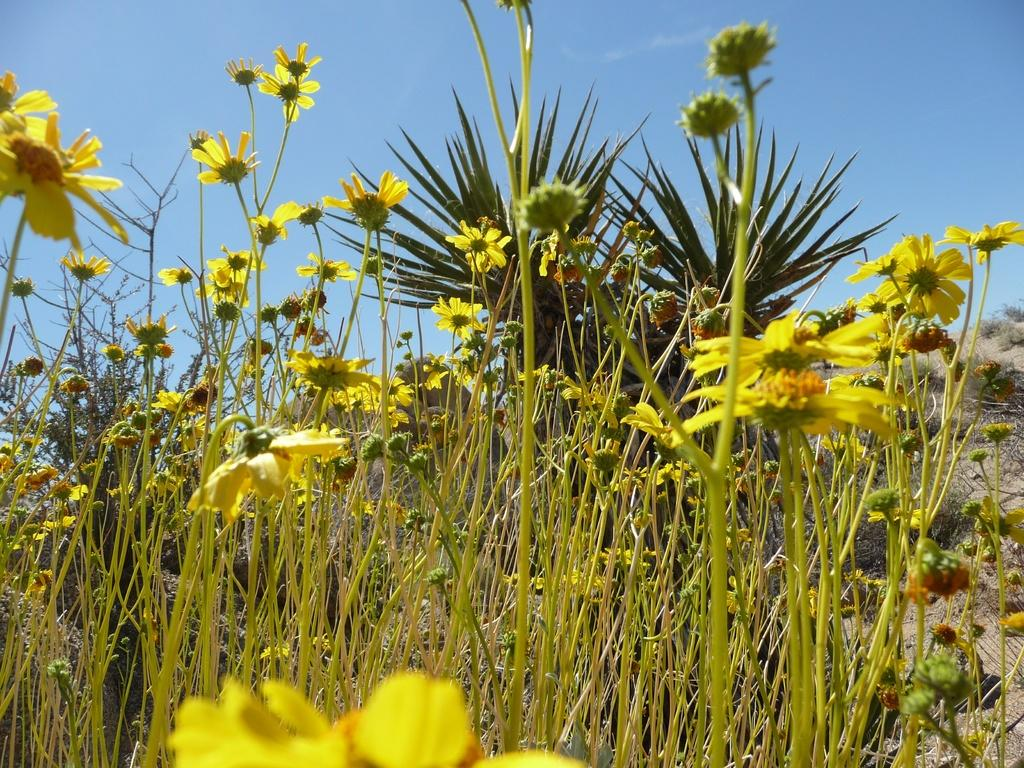What type of plants can be seen in the image? There are flower plants in the image. What can be seen in the background of the image? The sky is visible in the background of the image. Are there any other plants besides the flower plants in the image? Yes, there is a plant in the background of the image. What type of vegetation is on the right side of the image? There is grass on the right side of the image. What type of silk material is draped around the collar of the flower plants in the image? There is no silk material or collar present in the image; it features flower plants, the sky, a plant in the background, and grass on the right side. 